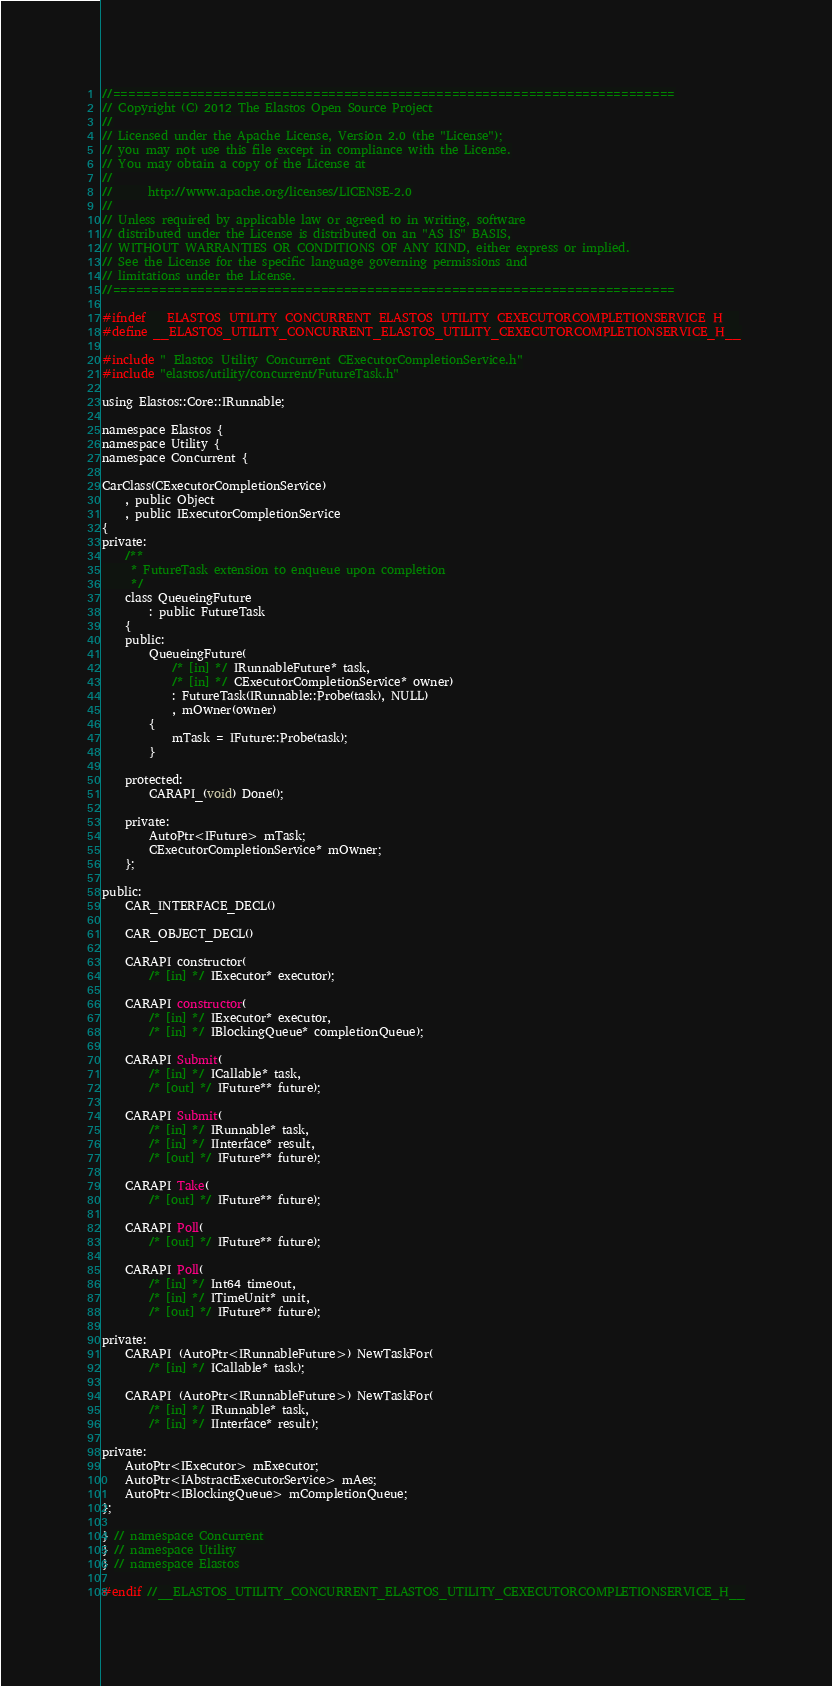<code> <loc_0><loc_0><loc_500><loc_500><_C_>//=========================================================================
// Copyright (C) 2012 The Elastos Open Source Project
//
// Licensed under the Apache License, Version 2.0 (the "License");
// you may not use this file except in compliance with the License.
// You may obtain a copy of the License at
//
//      http://www.apache.org/licenses/LICENSE-2.0
//
// Unless required by applicable law or agreed to in writing, software
// distributed under the License is distributed on an "AS IS" BASIS,
// WITHOUT WARRANTIES OR CONDITIONS OF ANY KIND, either express or implied.
// See the License for the specific language governing permissions and
// limitations under the License.
//=========================================================================

#ifndef __ELASTOS_UTILITY_CONCURRENT_ELASTOS_UTILITY_CEXECUTORCOMPLETIONSERVICE_H__
#define __ELASTOS_UTILITY_CONCURRENT_ELASTOS_UTILITY_CEXECUTORCOMPLETIONSERVICE_H__

#include "_Elastos_Utility_Concurrent_CExecutorCompletionService.h"
#include "elastos/utility/concurrent/FutureTask.h"

using Elastos::Core::IRunnable;

namespace Elastos {
namespace Utility {
namespace Concurrent {

CarClass(CExecutorCompletionService)
    , public Object
    , public IExecutorCompletionService
{
private:
    /**
     * FutureTask extension to enqueue upon completion
     */
    class QueueingFuture
        : public FutureTask
    {
    public:
        QueueingFuture(
            /* [in] */ IRunnableFuture* task,
            /* [in] */ CExecutorCompletionService* owner)
            : FutureTask(IRunnable::Probe(task), NULL)
            , mOwner(owner)
        {
            mTask = IFuture::Probe(task);
        }

    protected:
        CARAPI_(void) Done();

    private:
        AutoPtr<IFuture> mTask;
        CExecutorCompletionService* mOwner;
    };

public:
    CAR_INTERFACE_DECL()

    CAR_OBJECT_DECL()

    CARAPI constructor(
        /* [in] */ IExecutor* executor);

    CARAPI constructor(
        /* [in] */ IExecutor* executor,
        /* [in] */ IBlockingQueue* completionQueue);

    CARAPI Submit(
        /* [in] */ ICallable* task,
        /* [out] */ IFuture** future);

    CARAPI Submit(
        /* [in] */ IRunnable* task,
        /* [in] */ IInterface* result,
        /* [out] */ IFuture** future);

    CARAPI Take(
        /* [out] */ IFuture** future);

    CARAPI Poll(
        /* [out] */ IFuture** future);

    CARAPI Poll(
        /* [in] */ Int64 timeout,
        /* [in] */ ITimeUnit* unit,
        /* [out] */ IFuture** future);

private:
    CARAPI_(AutoPtr<IRunnableFuture>) NewTaskFor(
        /* [in] */ ICallable* task);

    CARAPI_(AutoPtr<IRunnableFuture>) NewTaskFor(
        /* [in] */ IRunnable* task,
        /* [in] */ IInterface* result);

private:
    AutoPtr<IExecutor> mExecutor;
    AutoPtr<IAbstractExecutorService> mAes;
    AutoPtr<IBlockingQueue> mCompletionQueue;
};

} // namespace Concurrent
} // namespace Utility
} // namespace Elastos

#endif //__ELASTOS_UTILITY_CONCURRENT_ELASTOS_UTILITY_CEXECUTORCOMPLETIONSERVICE_H__
</code> 